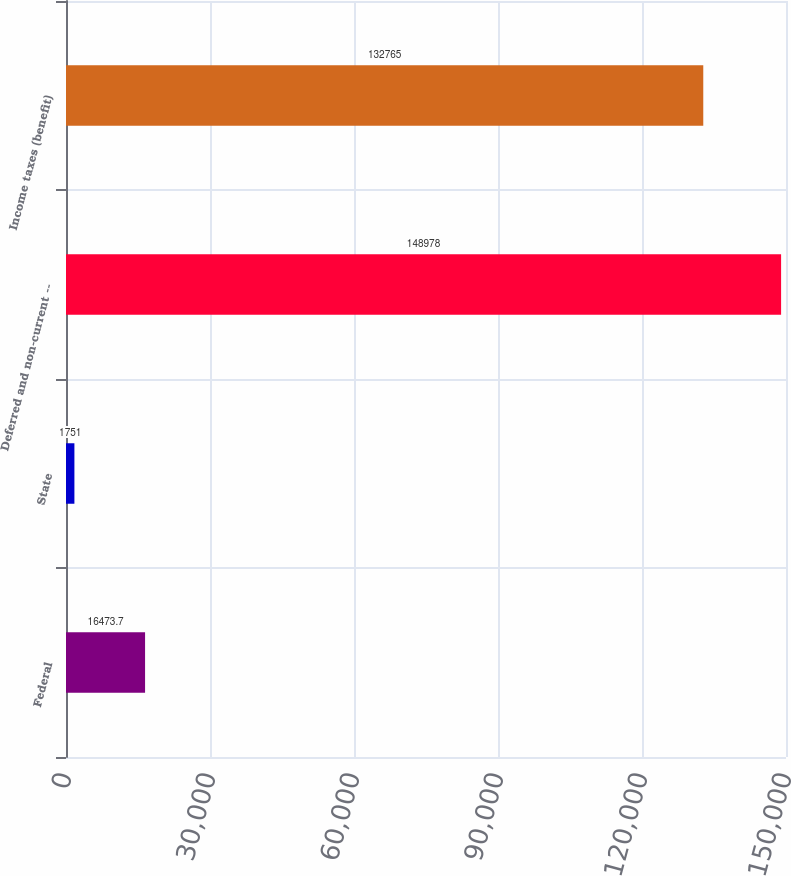<chart> <loc_0><loc_0><loc_500><loc_500><bar_chart><fcel>Federal<fcel>State<fcel>Deferred and non-current --<fcel>Income taxes (benefit)<nl><fcel>16473.7<fcel>1751<fcel>148978<fcel>132765<nl></chart> 